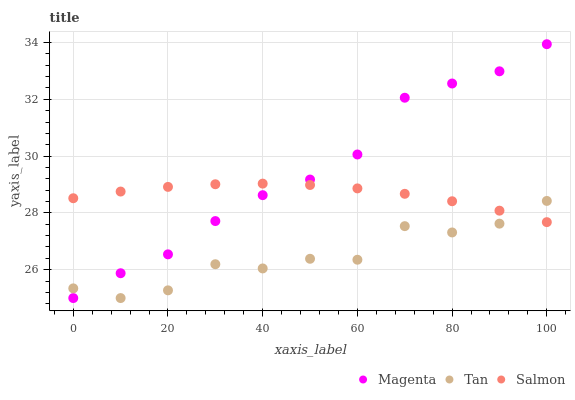Does Tan have the minimum area under the curve?
Answer yes or no. Yes. Does Magenta have the maximum area under the curve?
Answer yes or no. Yes. Does Salmon have the minimum area under the curve?
Answer yes or no. No. Does Salmon have the maximum area under the curve?
Answer yes or no. No. Is Salmon the smoothest?
Answer yes or no. Yes. Is Tan the roughest?
Answer yes or no. Yes. Is Tan the smoothest?
Answer yes or no. No. Is Salmon the roughest?
Answer yes or no. No. Does Magenta have the lowest value?
Answer yes or no. Yes. Does Salmon have the lowest value?
Answer yes or no. No. Does Magenta have the highest value?
Answer yes or no. Yes. Does Salmon have the highest value?
Answer yes or no. No. Does Magenta intersect Tan?
Answer yes or no. Yes. Is Magenta less than Tan?
Answer yes or no. No. Is Magenta greater than Tan?
Answer yes or no. No. 